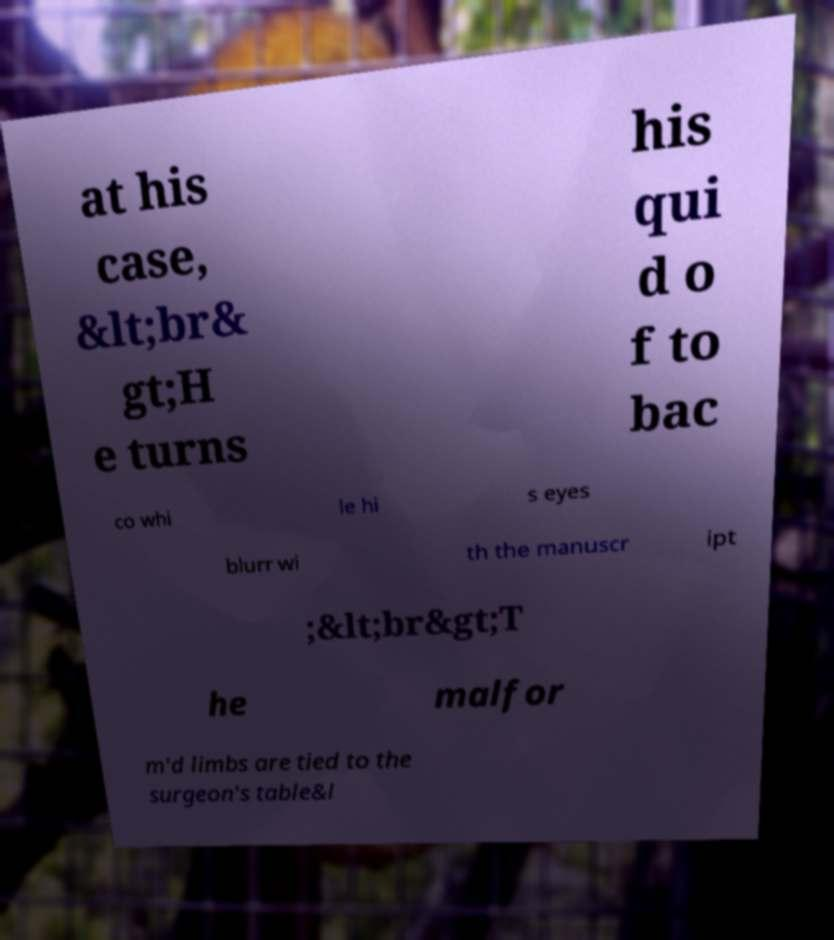What messages or text are displayed in this image? I need them in a readable, typed format. at his case, &lt;br& gt;H e turns his qui d o f to bac co whi le hi s eyes blurr wi th the manuscr ipt ;&lt;br&gt;T he malfor m'd limbs are tied to the surgeon's table&l 